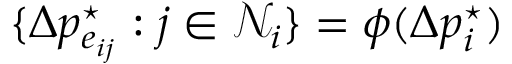Convert formula to latex. <formula><loc_0><loc_0><loc_500><loc_500>\{ \Delta p _ { e _ { i j } } ^ { ^ { * } } \colon j \in \mathcal { N } _ { i } \} = \phi ( \Delta p _ { i } ^ { ^ { * } } )</formula> 